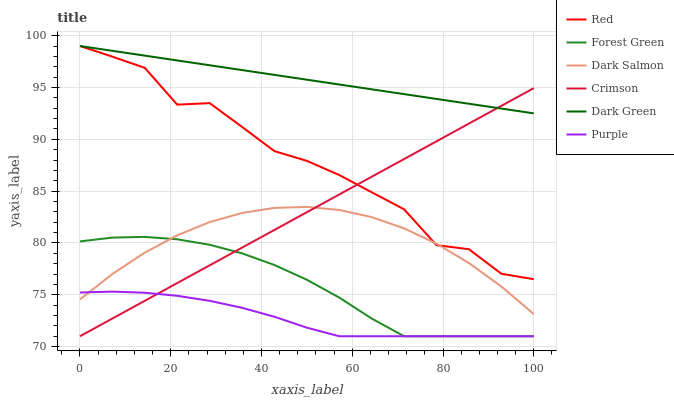Does Purple have the minimum area under the curve?
Answer yes or no. Yes. Does Dark Green have the maximum area under the curve?
Answer yes or no. Yes. Does Dark Salmon have the minimum area under the curve?
Answer yes or no. No. Does Dark Salmon have the maximum area under the curve?
Answer yes or no. No. Is Dark Green the smoothest?
Answer yes or no. Yes. Is Red the roughest?
Answer yes or no. Yes. Is Dark Salmon the smoothest?
Answer yes or no. No. Is Dark Salmon the roughest?
Answer yes or no. No. Does Dark Salmon have the lowest value?
Answer yes or no. No. Does Dark Green have the highest value?
Answer yes or no. Yes. Does Dark Salmon have the highest value?
Answer yes or no. No. Is Dark Salmon less than Dark Green?
Answer yes or no. Yes. Is Red greater than Forest Green?
Answer yes or no. Yes. Does Dark Salmon intersect Dark Green?
Answer yes or no. No. 